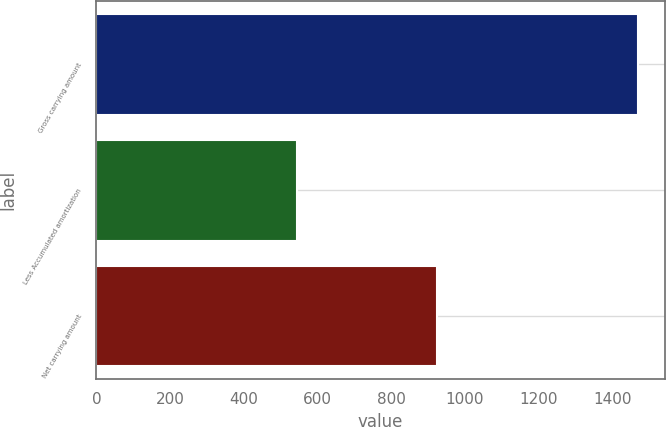Convert chart. <chart><loc_0><loc_0><loc_500><loc_500><bar_chart><fcel>Gross carrying amount<fcel>Less Accumulated amortization<fcel>Net carrying amount<nl><fcel>1469<fcel>544<fcel>925<nl></chart> 